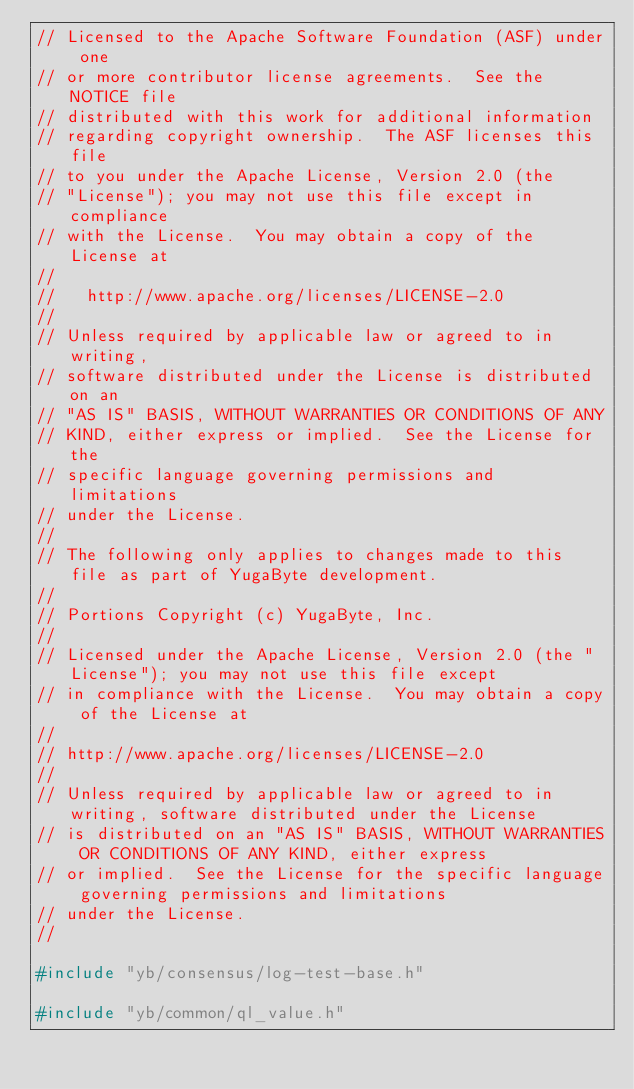Convert code to text. <code><loc_0><loc_0><loc_500><loc_500><_C++_>// Licensed to the Apache Software Foundation (ASF) under one
// or more contributor license agreements.  See the NOTICE file
// distributed with this work for additional information
// regarding copyright ownership.  The ASF licenses this file
// to you under the Apache License, Version 2.0 (the
// "License"); you may not use this file except in compliance
// with the License.  You may obtain a copy of the License at
//
//   http://www.apache.org/licenses/LICENSE-2.0
//
// Unless required by applicable law or agreed to in writing,
// software distributed under the License is distributed on an
// "AS IS" BASIS, WITHOUT WARRANTIES OR CONDITIONS OF ANY
// KIND, either express or implied.  See the License for the
// specific language governing permissions and limitations
// under the License.
//
// The following only applies to changes made to this file as part of YugaByte development.
//
// Portions Copyright (c) YugaByte, Inc.
//
// Licensed under the Apache License, Version 2.0 (the "License"); you may not use this file except
// in compliance with the License.  You may obtain a copy of the License at
//
// http://www.apache.org/licenses/LICENSE-2.0
//
// Unless required by applicable law or agreed to in writing, software distributed under the License
// is distributed on an "AS IS" BASIS, WITHOUT WARRANTIES OR CONDITIONS OF ANY KIND, either express
// or implied.  See the License for the specific language governing permissions and limitations
// under the License.
//

#include "yb/consensus/log-test-base.h"

#include "yb/common/ql_value.h"
</code> 